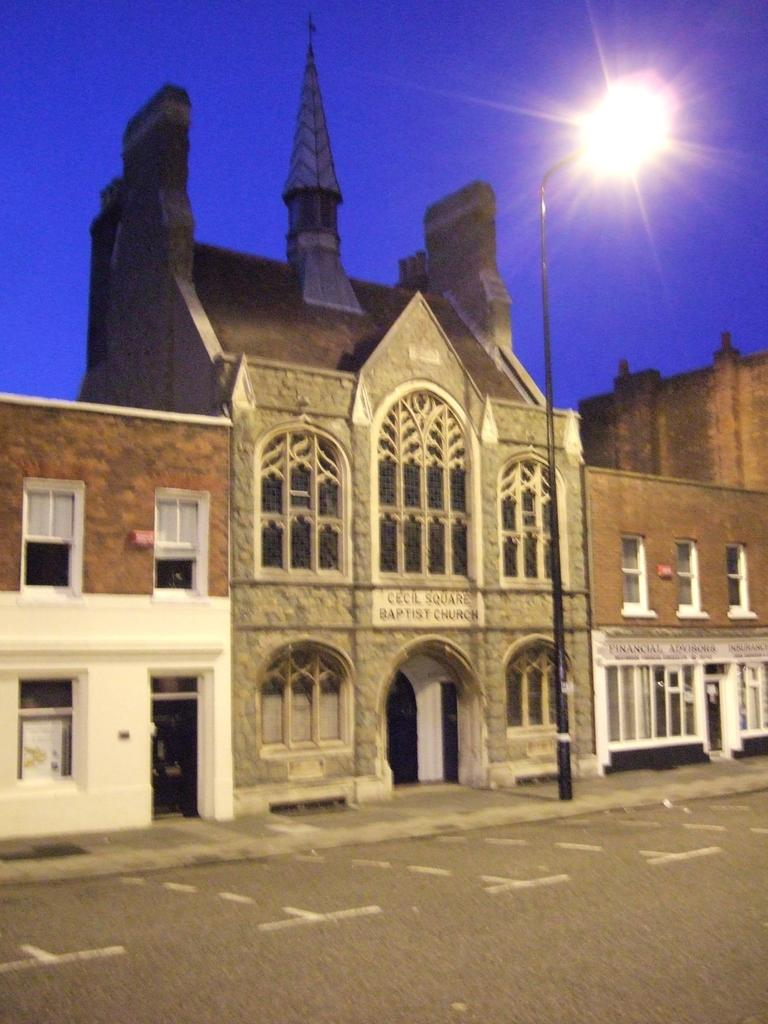What type of structure is present in the image? There is a building in the image. What feature can be observed on the building? The building has windows. What is written or displayed on a visible board in the image? There is a sign board with text on it. What type of object can be seen near the building? There is a street pole in the image. What part of the ground is visible in the image? The pathway is visible in the image. What part of the natural environment is visible in the image? The sky is visible in the image. What type of mist can be seen surrounding the building in the image? There is no mist present in the image; the sky is visible and appears clear. What type of sail is attached to the building in the image? There is no sail present in the image; it is a building with windows and a sign board. 